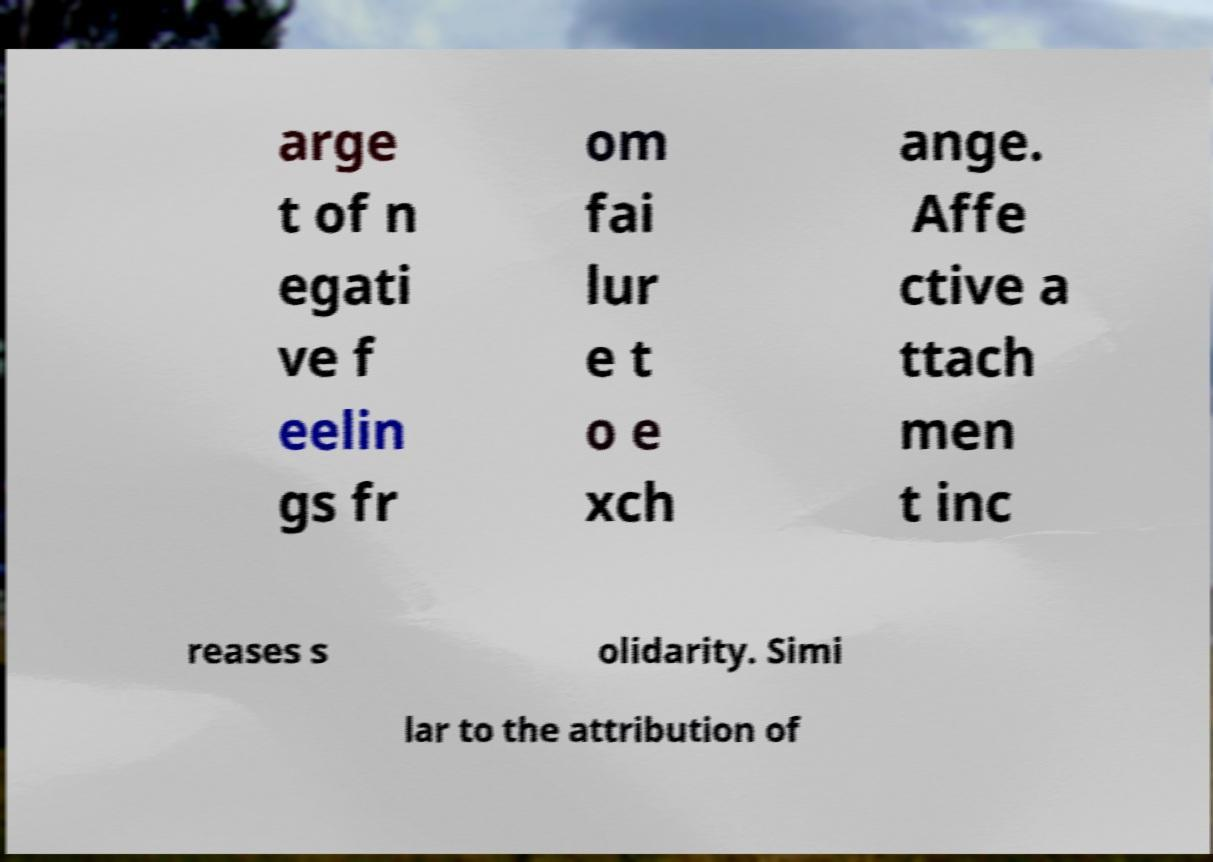For documentation purposes, I need the text within this image transcribed. Could you provide that? arge t of n egati ve f eelin gs fr om fai lur e t o e xch ange. Affe ctive a ttach men t inc reases s olidarity. Simi lar to the attribution of 